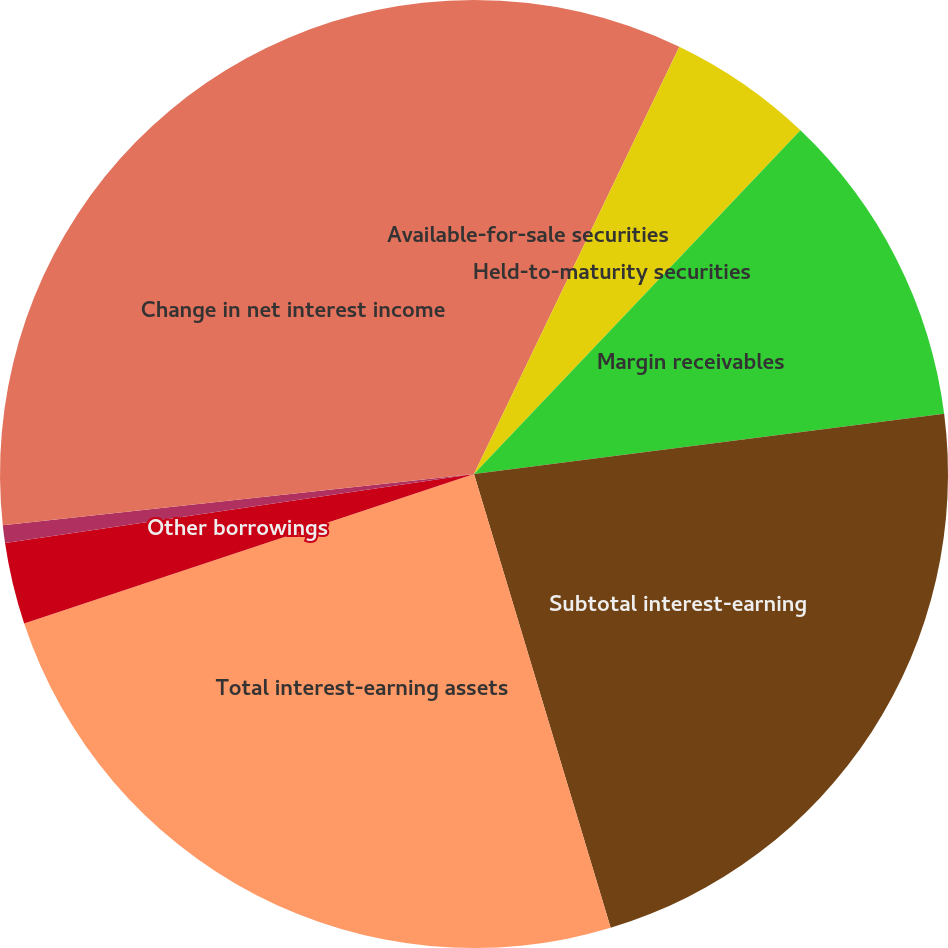Convert chart to OTSL. <chart><loc_0><loc_0><loc_500><loc_500><pie_chart><fcel>Available-for-sale securities<fcel>Held-to-maturity securities<fcel>Margin receivables<fcel>Subtotal interest-earning<fcel>Total interest-earning assets<fcel>Other borrowings<fcel>Corporate debt<fcel>Change in net interest income<nl><fcel>7.13%<fcel>4.96%<fcel>10.88%<fcel>22.37%<fcel>24.55%<fcel>2.78%<fcel>0.6%<fcel>26.72%<nl></chart> 